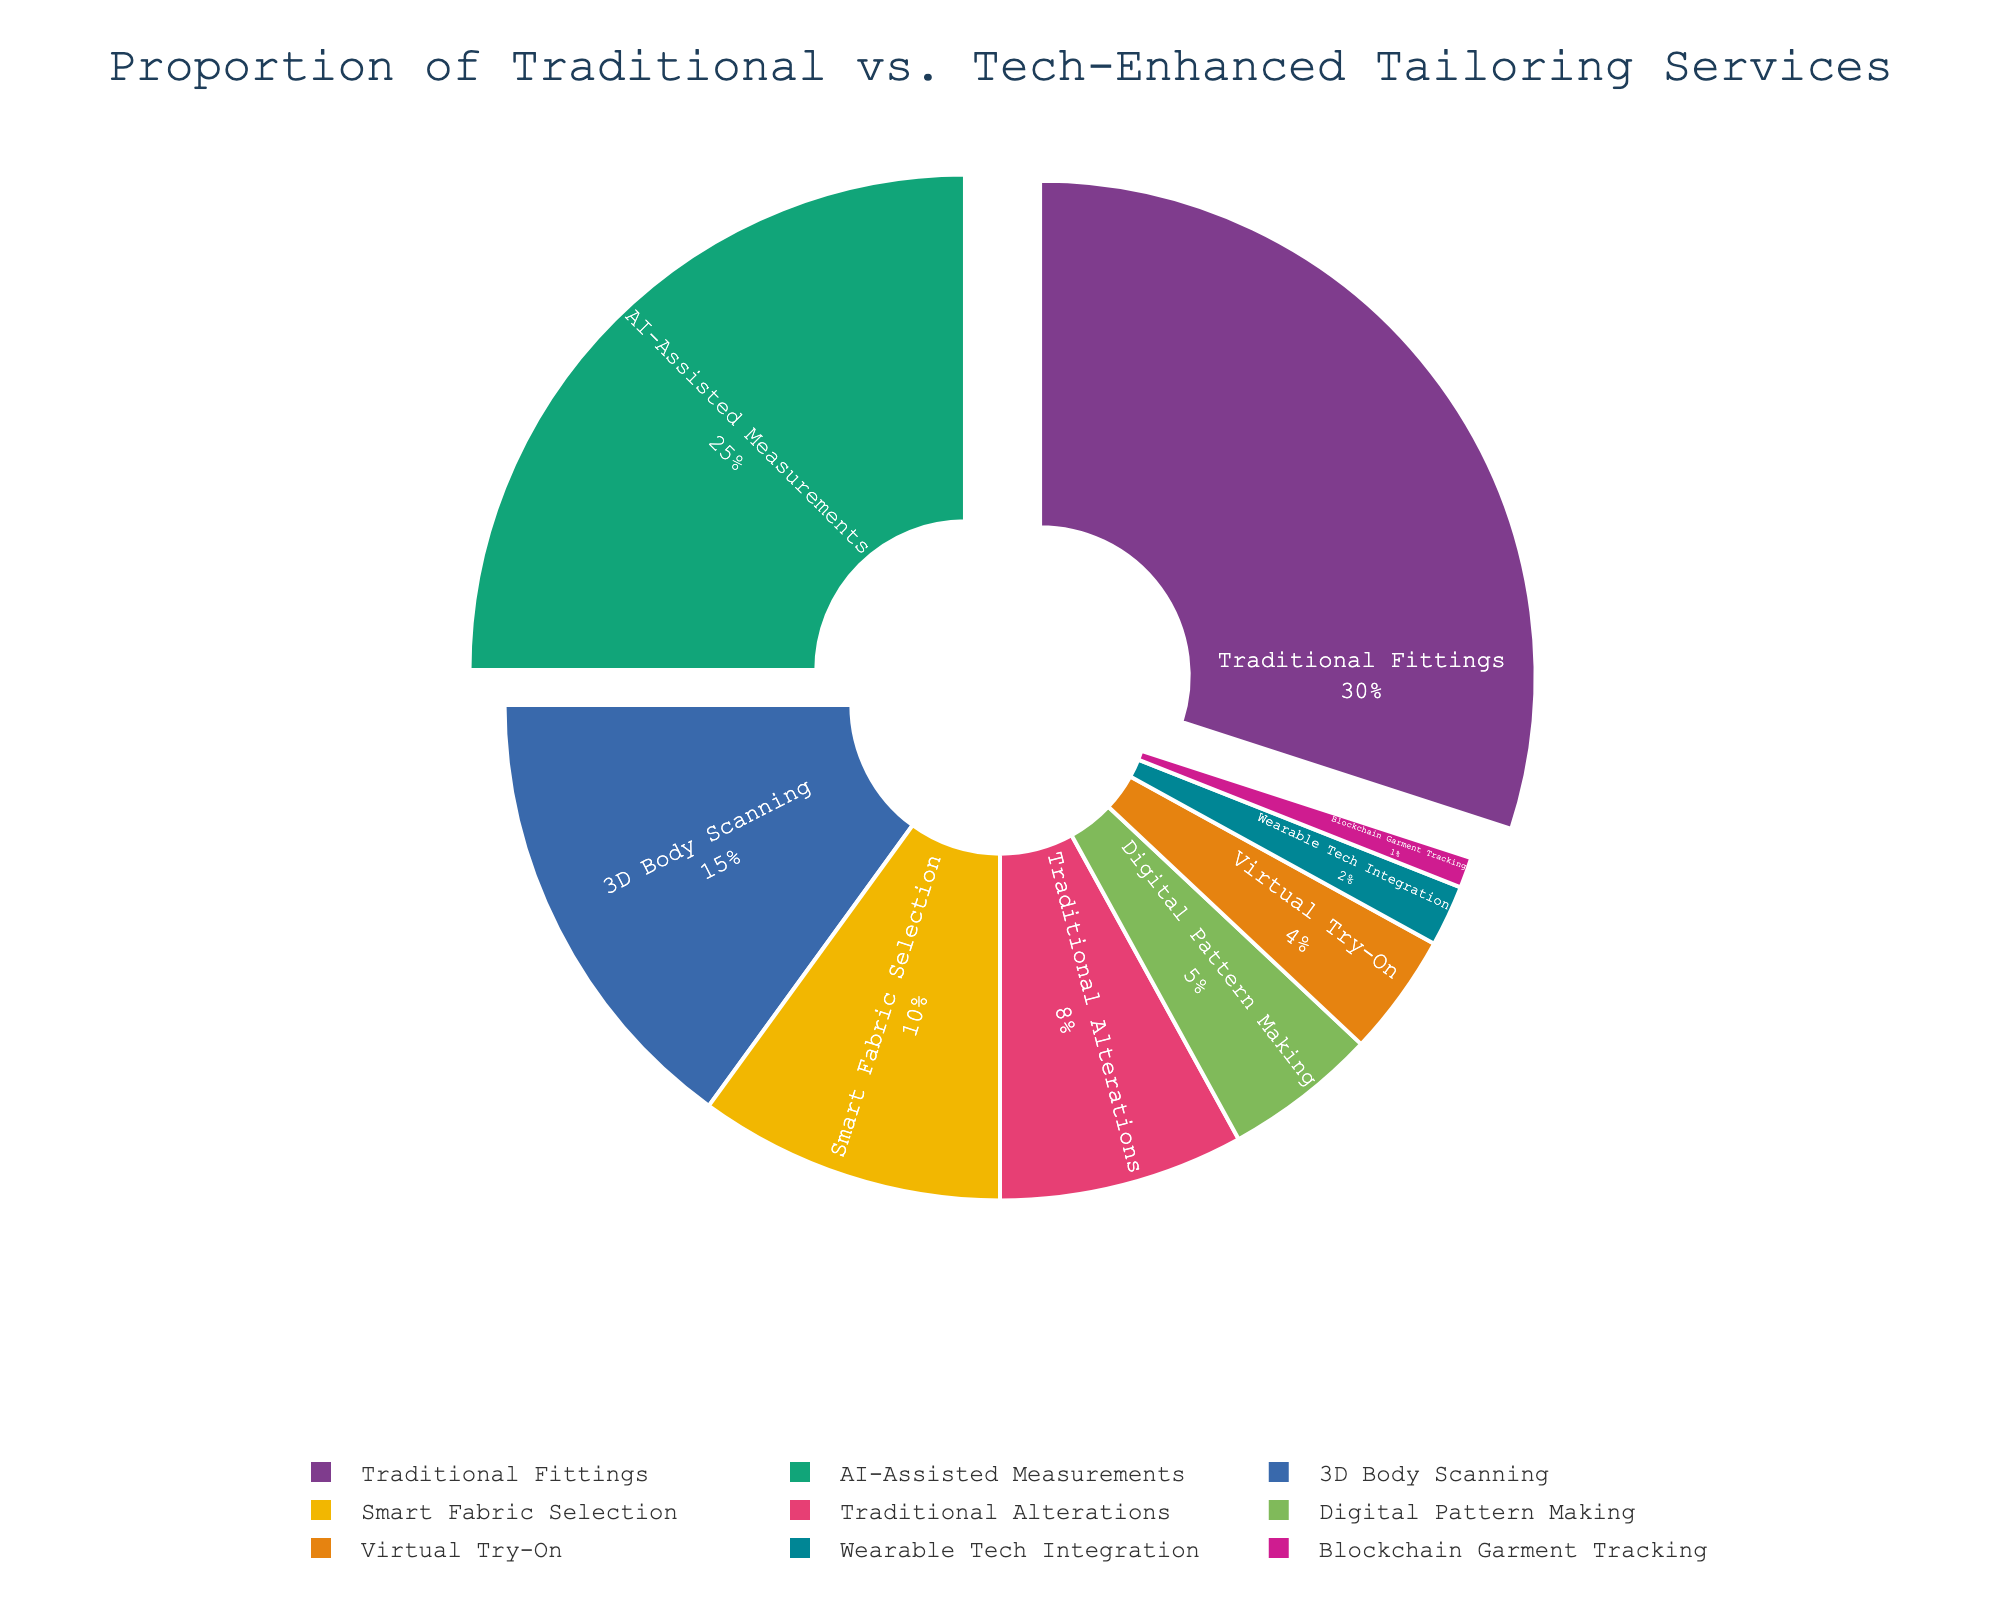What's the most common service offered in your tailoring shop? To find the most common service, look for the segment with the largest percentage in the pie chart. This is 'Traditional Fittings', which has 30%.
Answer: Traditional Fittings What's the combined percentage of AI-Assisted Measurements and 3D Body Scanning? Sum the percentages of AI-Assisted Measurements (25%) and 3D Body Scanning (15%). So, 25% + 15% = 40%.
Answer: 40% How does the number of tech-enhanced services compare to traditional services offered? Count the segments categorized as tech-enhanced (AI-Assisted Measurements, 3D Body Scanning, Smart Fabric Selection, Digital Pattern Making, Virtual Try-On, Wearable Tech Integration, Blockchain Garment Tracking) and traditional (Traditional Fittings, Traditional Alterations). There are 7 tech-enhanced and 2 traditional services.
Answer: 7 tech-enhanced vs 2 traditional Which service takes up the smallest proportion? The smallest slice in the pie chart corresponds to 'Blockchain Garment Tracking' with 1%.
Answer: Blockchain Garment Tracking Among the tech-enhanced services, which one has the highest proportion? Look among the tech-enhanced services (AI-Assisted Measurements, 3D Body Scanning, Smart Fabric Selection, Digital Pattern Making, Virtual Try-On, Wearable Tech Integration, Blockchain Garment Tracking) and find the largest segment. AI-Assisted Measurements has the highest proportion at 25%.
Answer: AI-Assisted Measurements How does the proportion of Traditional Fittings compare to Smart Fabric Selection? Compare Traditional Fittings (30%) and Smart Fabric Selection (10%). Traditional Fittings has a higher proportion.
Answer: Traditional Fittings has a higher proportion What's the combined percentage of all traditional services? Add the percentages of Traditional Fittings (30%) and Traditional Alterations (8%). So, 30% + 8% = 38%.
Answer: 38% What's the difference in percentage between the largest and smallest service offerings? Subtract the smallest percentage (Blockchain Garment Tracking, 1%) from the largest (Traditional Fittings, 30%). So, 30% - 1% = 29%.
Answer: 29% Are there more services with a proportion above or below 10%? Count the services above 10% (Traditional Fittings, AI-Assisted Measurements, 3D Body Scanning), which are 3, and below 10% (Smart Fabric Selection, Traditional Alterations, Digital Pattern Making, Virtual Try-On, Wearable Tech Integration, Blockchain Garment Tracking), which are 6. There are more services below 10%.
Answer: More services below 10% What is the average percentage of tech-enhanced services? Sum the percentages of tech-enhanced services (25%, 15%, 10%, 5%, 4%, 2%, 1%) and then divide by the number of tech-enhanced services (7). The total is 62%, and the average is 62/7 ≈ 8.86%.
Answer: 8.86% 